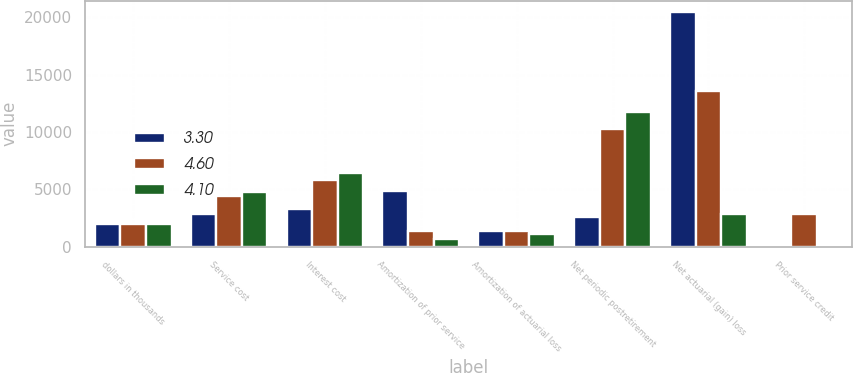Convert chart to OTSL. <chart><loc_0><loc_0><loc_500><loc_500><stacked_bar_chart><ecel><fcel>dollars in thousands<fcel>Service cost<fcel>Interest cost<fcel>Amortization of prior service<fcel>Amortization of actuarial loss<fcel>Net periodic postretirement<fcel>Net actuarial (gain) loss<fcel>Prior service credit<nl><fcel>3.3<fcel>2013<fcel>2830<fcel>3260<fcel>4863<fcel>1372<fcel>2599<fcel>20444<fcel>0<nl><fcel>4.6<fcel>2012<fcel>4409<fcel>5851<fcel>1372<fcel>1346<fcel>10234<fcel>13562<fcel>2830<nl><fcel>4.1<fcel>2011<fcel>4789<fcel>6450<fcel>674<fcel>1149<fcel>11714<fcel>2853<fcel>0<nl></chart> 